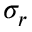<formula> <loc_0><loc_0><loc_500><loc_500>\sigma _ { r }</formula> 